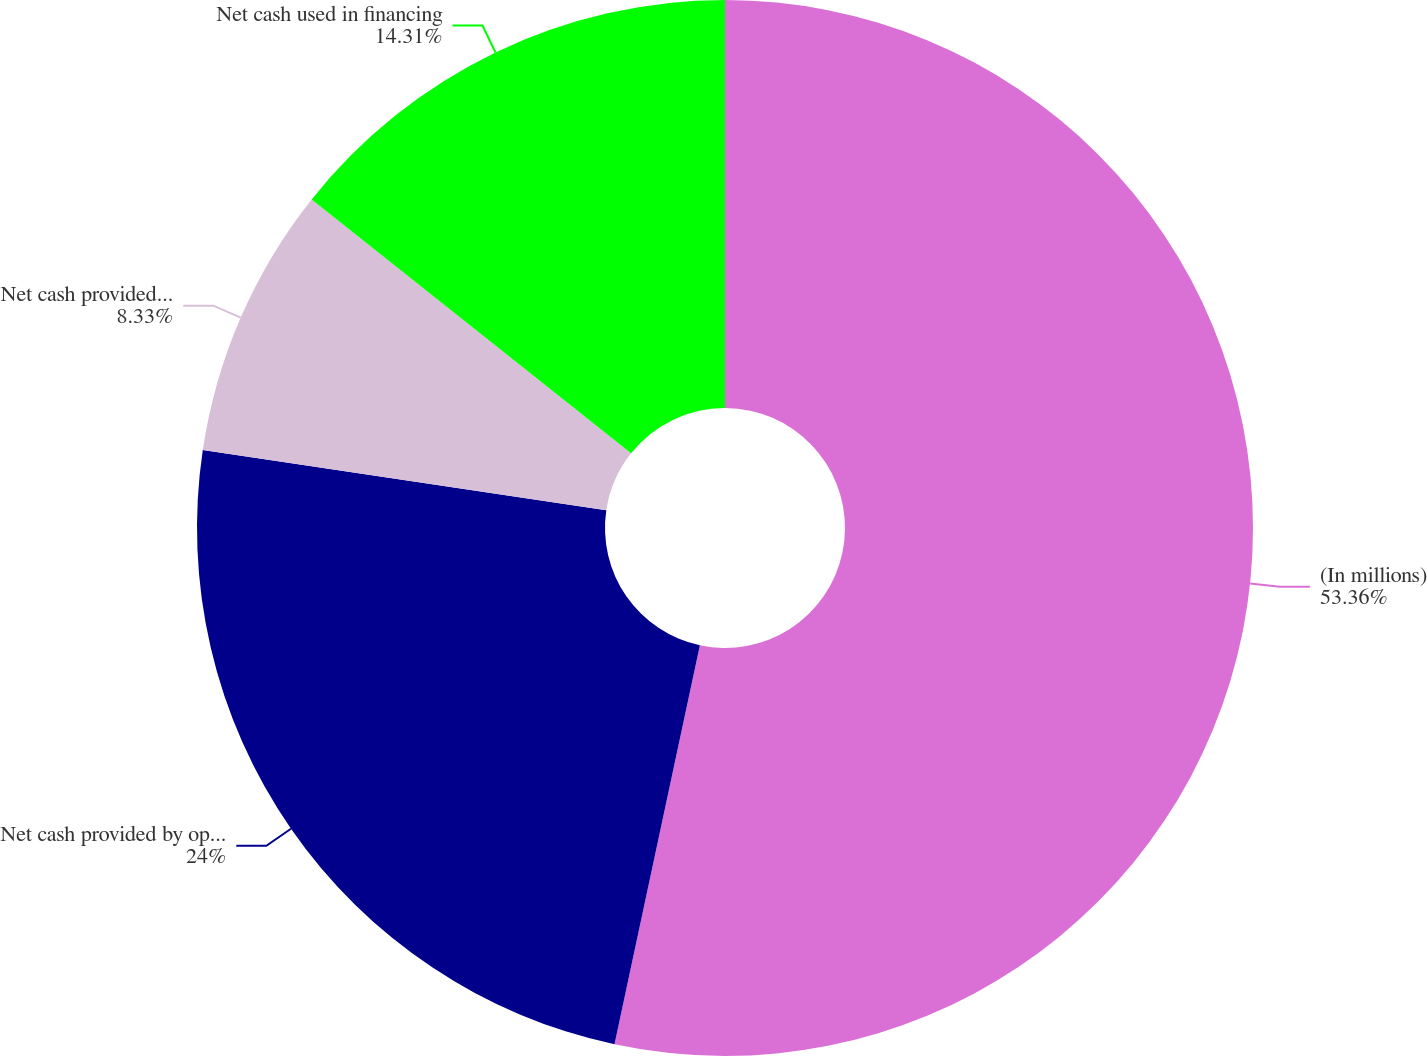<chart> <loc_0><loc_0><loc_500><loc_500><pie_chart><fcel>(In millions)<fcel>Net cash provided by operating<fcel>Net cash provided by (used in)<fcel>Net cash used in financing<nl><fcel>53.35%<fcel>24.0%<fcel>8.33%<fcel>14.31%<nl></chart> 